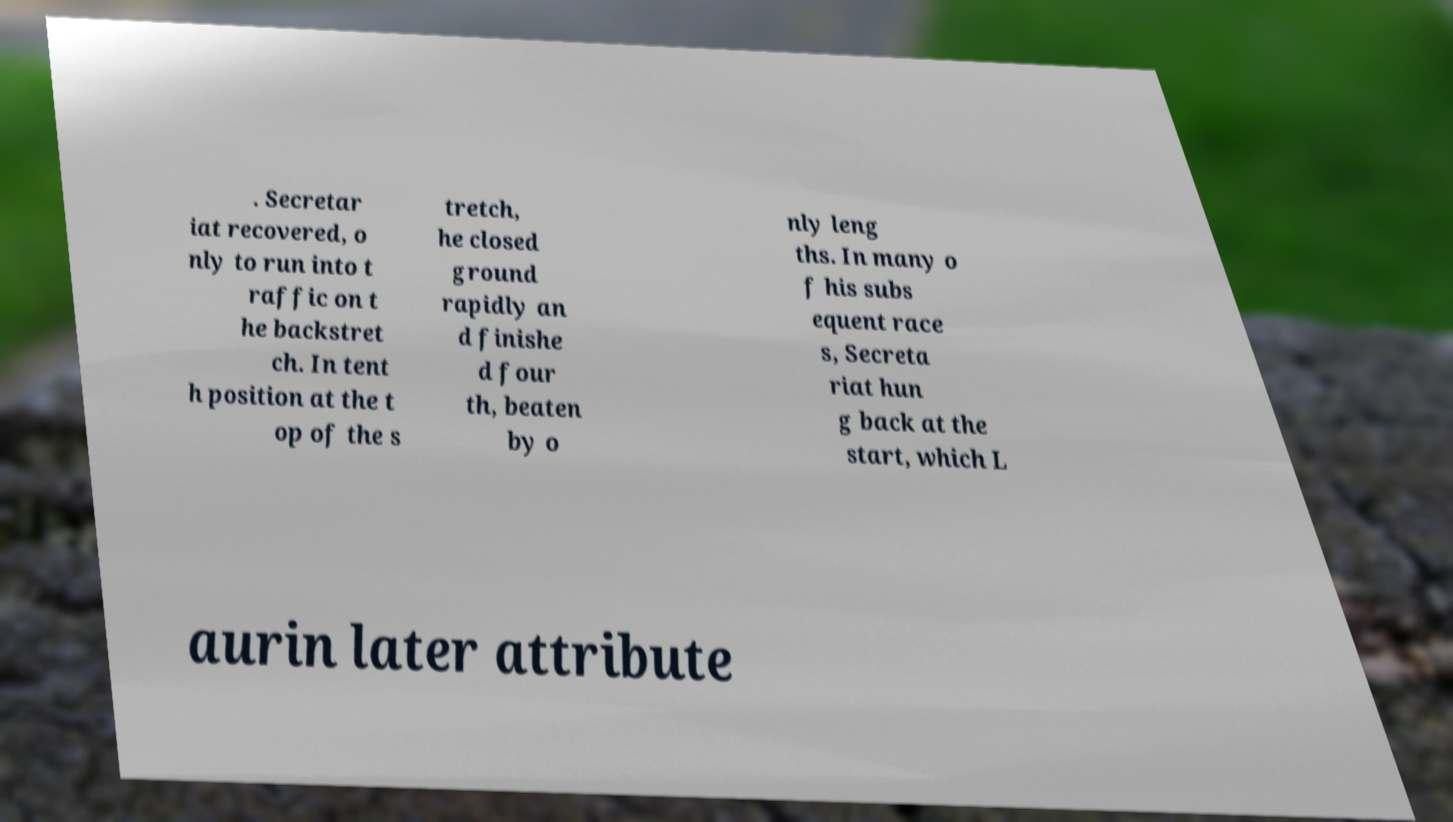Please identify and transcribe the text found in this image. . Secretar iat recovered, o nly to run into t raffic on t he backstret ch. In tent h position at the t op of the s tretch, he closed ground rapidly an d finishe d four th, beaten by o nly leng ths. In many o f his subs equent race s, Secreta riat hun g back at the start, which L aurin later attribute 